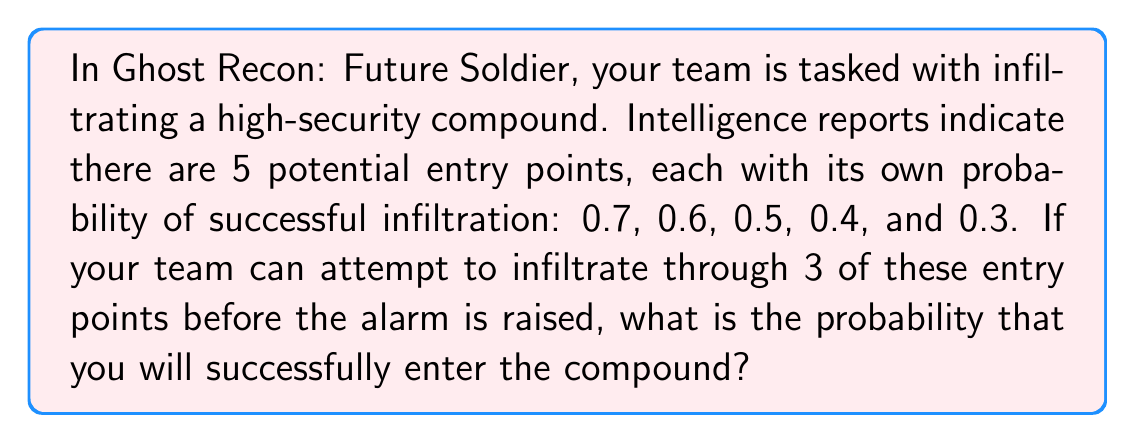Can you solve this math problem? Let's approach this step-by-step:

1) First, we need to calculate the probability of failing to infiltrate through all 3 chosen entry points.

2) The probability of failing to infiltrate through a single entry point is the complement of the probability of success. For example, for the first entry point with a 0.7 success rate, the failure rate is $1 - 0.7 = 0.3$.

3) To maximize our chances, we'll choose the three entry points with the highest probabilities of success: 0.7, 0.6, and 0.5.

4) The probability of failing all three attempts is the product of the individual failure probabilities:

   $$(1 - 0.7) \times (1 - 0.6) \times (1 - 0.5) = 0.3 \times 0.4 \times 0.5 = 0.06$$

5) Therefore, the probability of succeeding (i.e., infiltrating through at least one entry point) is the complement of this:

   $$1 - 0.06 = 0.94$$

6) We can also calculate this directly:

   $$1 - [(1 - 0.7) \times (1 - 0.6) \times (1 - 0.5)]$$

   $$= 1 - (0.3 \times 0.4 \times 0.5)$$
   
   $$= 1 - 0.06 = 0.94$$

This result can be interpreted as a 94% chance of successfully infiltrating the compound.
Answer: 0.94 or 94% 